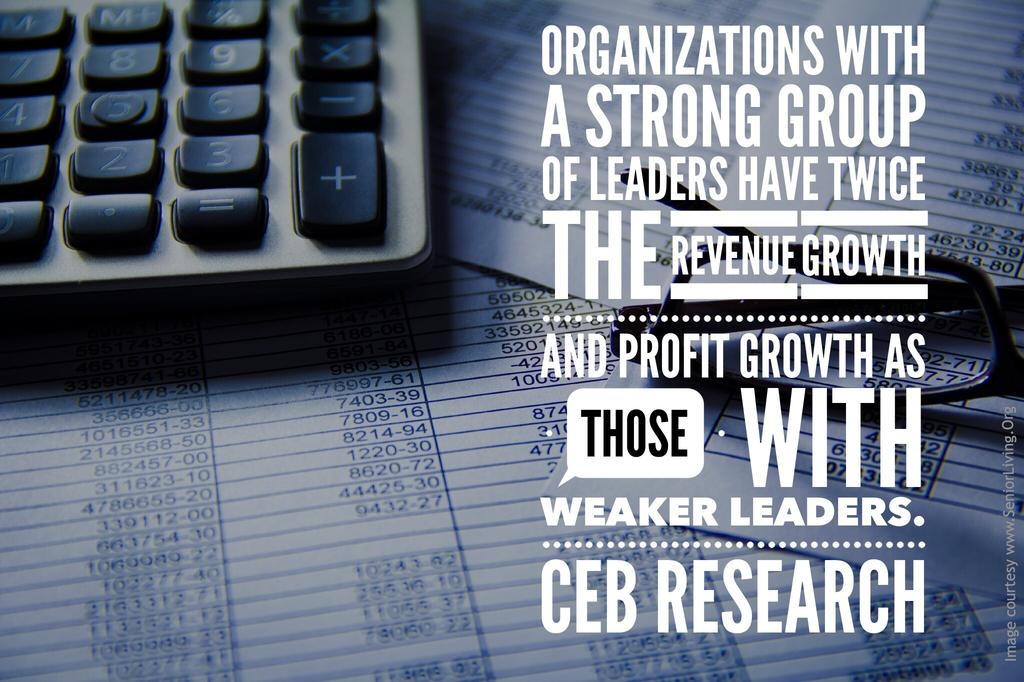<image>
Describe the image concisely. a keyboard on top of pages that is labeled 'organizations with a strong group of leaders have twice...' on it 